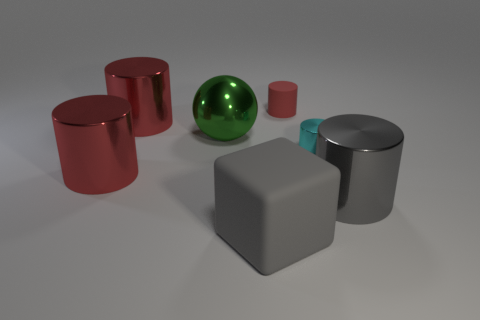Subtract all gray cylinders. How many cylinders are left? 4 Subtract all balls. How many objects are left? 6 Subtract all gray cylinders. How many cylinders are left? 4 Subtract all cyan cylinders. How many cyan balls are left? 0 Subtract all red matte cylinders. Subtract all cyan things. How many objects are left? 5 Add 4 gray rubber cubes. How many gray rubber cubes are left? 5 Add 6 tiny purple rubber balls. How many tiny purple rubber balls exist? 6 Add 2 red cylinders. How many objects exist? 9 Subtract 0 yellow cubes. How many objects are left? 7 Subtract all cyan cylinders. Subtract all green balls. How many cylinders are left? 4 